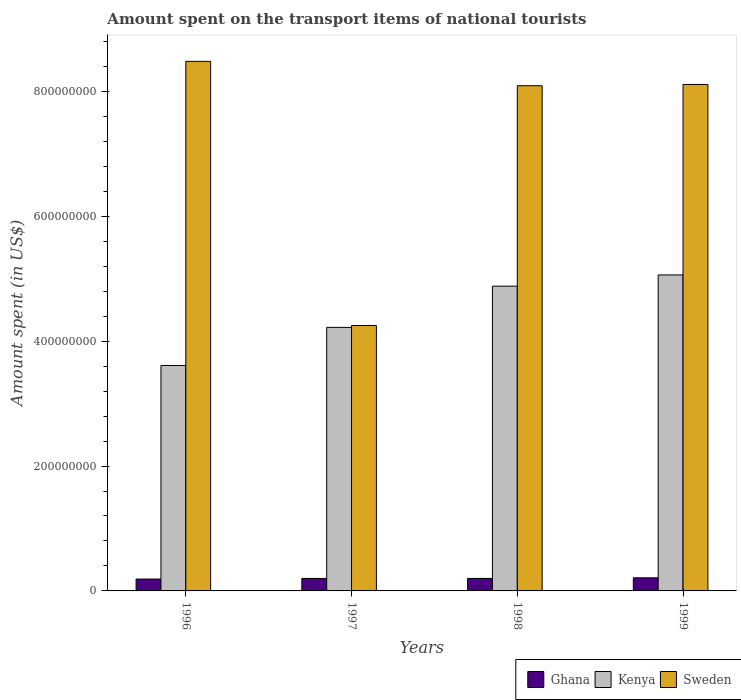How many bars are there on the 4th tick from the left?
Provide a succinct answer. 3. How many bars are there on the 1st tick from the right?
Make the answer very short. 3. What is the amount spent on the transport items of national tourists in Ghana in 1997?
Keep it short and to the point. 2.00e+07. Across all years, what is the maximum amount spent on the transport items of national tourists in Sweden?
Offer a very short reply. 8.48e+08. Across all years, what is the minimum amount spent on the transport items of national tourists in Kenya?
Offer a very short reply. 3.61e+08. In which year was the amount spent on the transport items of national tourists in Kenya maximum?
Your response must be concise. 1999. In which year was the amount spent on the transport items of national tourists in Kenya minimum?
Give a very brief answer. 1996. What is the total amount spent on the transport items of national tourists in Sweden in the graph?
Give a very brief answer. 2.89e+09. What is the difference between the amount spent on the transport items of national tourists in Kenya in 1997 and that in 1999?
Your answer should be very brief. -8.40e+07. What is the difference between the amount spent on the transport items of national tourists in Kenya in 1998 and the amount spent on the transport items of national tourists in Sweden in 1997?
Keep it short and to the point. 6.30e+07. What is the average amount spent on the transport items of national tourists in Kenya per year?
Ensure brevity in your answer.  4.44e+08. In the year 1999, what is the difference between the amount spent on the transport items of national tourists in Sweden and amount spent on the transport items of national tourists in Ghana?
Ensure brevity in your answer.  7.90e+08. What is the ratio of the amount spent on the transport items of national tourists in Kenya in 1998 to that in 1999?
Your response must be concise. 0.96. What is the difference between the highest and the second highest amount spent on the transport items of national tourists in Kenya?
Offer a very short reply. 1.80e+07. What is the difference between the highest and the lowest amount spent on the transport items of national tourists in Ghana?
Provide a succinct answer. 2.00e+06. Is the sum of the amount spent on the transport items of national tourists in Kenya in 1996 and 1998 greater than the maximum amount spent on the transport items of national tourists in Ghana across all years?
Your answer should be very brief. Yes. What does the 2nd bar from the left in 1998 represents?
Make the answer very short. Kenya. Is it the case that in every year, the sum of the amount spent on the transport items of national tourists in Kenya and amount spent on the transport items of national tourists in Ghana is greater than the amount spent on the transport items of national tourists in Sweden?
Provide a succinct answer. No. How many bars are there?
Provide a succinct answer. 12. Are all the bars in the graph horizontal?
Your response must be concise. No. How many years are there in the graph?
Offer a very short reply. 4. What is the difference between two consecutive major ticks on the Y-axis?
Ensure brevity in your answer.  2.00e+08. Are the values on the major ticks of Y-axis written in scientific E-notation?
Ensure brevity in your answer.  No. Where does the legend appear in the graph?
Ensure brevity in your answer.  Bottom right. How many legend labels are there?
Give a very brief answer. 3. What is the title of the graph?
Provide a short and direct response. Amount spent on the transport items of national tourists. Does "High income: nonOECD" appear as one of the legend labels in the graph?
Give a very brief answer. No. What is the label or title of the X-axis?
Your response must be concise. Years. What is the label or title of the Y-axis?
Provide a succinct answer. Amount spent (in US$). What is the Amount spent (in US$) of Ghana in 1996?
Your answer should be very brief. 1.90e+07. What is the Amount spent (in US$) in Kenya in 1996?
Provide a succinct answer. 3.61e+08. What is the Amount spent (in US$) in Sweden in 1996?
Offer a terse response. 8.48e+08. What is the Amount spent (in US$) of Ghana in 1997?
Provide a short and direct response. 2.00e+07. What is the Amount spent (in US$) of Kenya in 1997?
Provide a short and direct response. 4.22e+08. What is the Amount spent (in US$) in Sweden in 1997?
Your answer should be very brief. 4.25e+08. What is the Amount spent (in US$) of Kenya in 1998?
Offer a very short reply. 4.88e+08. What is the Amount spent (in US$) of Sweden in 1998?
Make the answer very short. 8.09e+08. What is the Amount spent (in US$) of Ghana in 1999?
Provide a succinct answer. 2.10e+07. What is the Amount spent (in US$) of Kenya in 1999?
Offer a terse response. 5.06e+08. What is the Amount spent (in US$) of Sweden in 1999?
Keep it short and to the point. 8.11e+08. Across all years, what is the maximum Amount spent (in US$) in Ghana?
Give a very brief answer. 2.10e+07. Across all years, what is the maximum Amount spent (in US$) of Kenya?
Provide a short and direct response. 5.06e+08. Across all years, what is the maximum Amount spent (in US$) in Sweden?
Make the answer very short. 8.48e+08. Across all years, what is the minimum Amount spent (in US$) in Ghana?
Offer a very short reply. 1.90e+07. Across all years, what is the minimum Amount spent (in US$) in Kenya?
Your answer should be compact. 3.61e+08. Across all years, what is the minimum Amount spent (in US$) in Sweden?
Your answer should be compact. 4.25e+08. What is the total Amount spent (in US$) in Ghana in the graph?
Offer a very short reply. 8.00e+07. What is the total Amount spent (in US$) in Kenya in the graph?
Offer a terse response. 1.78e+09. What is the total Amount spent (in US$) in Sweden in the graph?
Provide a short and direct response. 2.89e+09. What is the difference between the Amount spent (in US$) of Ghana in 1996 and that in 1997?
Your answer should be compact. -1.00e+06. What is the difference between the Amount spent (in US$) in Kenya in 1996 and that in 1997?
Your answer should be very brief. -6.10e+07. What is the difference between the Amount spent (in US$) of Sweden in 1996 and that in 1997?
Keep it short and to the point. 4.23e+08. What is the difference between the Amount spent (in US$) in Kenya in 1996 and that in 1998?
Offer a very short reply. -1.27e+08. What is the difference between the Amount spent (in US$) in Sweden in 1996 and that in 1998?
Your answer should be very brief. 3.90e+07. What is the difference between the Amount spent (in US$) of Kenya in 1996 and that in 1999?
Offer a terse response. -1.45e+08. What is the difference between the Amount spent (in US$) in Sweden in 1996 and that in 1999?
Offer a terse response. 3.70e+07. What is the difference between the Amount spent (in US$) of Kenya in 1997 and that in 1998?
Your response must be concise. -6.60e+07. What is the difference between the Amount spent (in US$) in Sweden in 1997 and that in 1998?
Provide a short and direct response. -3.84e+08. What is the difference between the Amount spent (in US$) of Kenya in 1997 and that in 1999?
Offer a very short reply. -8.40e+07. What is the difference between the Amount spent (in US$) in Sweden in 1997 and that in 1999?
Ensure brevity in your answer.  -3.86e+08. What is the difference between the Amount spent (in US$) in Kenya in 1998 and that in 1999?
Ensure brevity in your answer.  -1.80e+07. What is the difference between the Amount spent (in US$) of Ghana in 1996 and the Amount spent (in US$) of Kenya in 1997?
Provide a succinct answer. -4.03e+08. What is the difference between the Amount spent (in US$) of Ghana in 1996 and the Amount spent (in US$) of Sweden in 1997?
Provide a short and direct response. -4.06e+08. What is the difference between the Amount spent (in US$) in Kenya in 1996 and the Amount spent (in US$) in Sweden in 1997?
Provide a short and direct response. -6.40e+07. What is the difference between the Amount spent (in US$) in Ghana in 1996 and the Amount spent (in US$) in Kenya in 1998?
Make the answer very short. -4.69e+08. What is the difference between the Amount spent (in US$) of Ghana in 1996 and the Amount spent (in US$) of Sweden in 1998?
Offer a very short reply. -7.90e+08. What is the difference between the Amount spent (in US$) of Kenya in 1996 and the Amount spent (in US$) of Sweden in 1998?
Ensure brevity in your answer.  -4.48e+08. What is the difference between the Amount spent (in US$) in Ghana in 1996 and the Amount spent (in US$) in Kenya in 1999?
Provide a short and direct response. -4.87e+08. What is the difference between the Amount spent (in US$) of Ghana in 1996 and the Amount spent (in US$) of Sweden in 1999?
Give a very brief answer. -7.92e+08. What is the difference between the Amount spent (in US$) in Kenya in 1996 and the Amount spent (in US$) in Sweden in 1999?
Your answer should be compact. -4.50e+08. What is the difference between the Amount spent (in US$) in Ghana in 1997 and the Amount spent (in US$) in Kenya in 1998?
Keep it short and to the point. -4.68e+08. What is the difference between the Amount spent (in US$) in Ghana in 1997 and the Amount spent (in US$) in Sweden in 1998?
Your answer should be compact. -7.89e+08. What is the difference between the Amount spent (in US$) of Kenya in 1997 and the Amount spent (in US$) of Sweden in 1998?
Ensure brevity in your answer.  -3.87e+08. What is the difference between the Amount spent (in US$) in Ghana in 1997 and the Amount spent (in US$) in Kenya in 1999?
Provide a short and direct response. -4.86e+08. What is the difference between the Amount spent (in US$) of Ghana in 1997 and the Amount spent (in US$) of Sweden in 1999?
Provide a succinct answer. -7.91e+08. What is the difference between the Amount spent (in US$) in Kenya in 1997 and the Amount spent (in US$) in Sweden in 1999?
Your response must be concise. -3.89e+08. What is the difference between the Amount spent (in US$) of Ghana in 1998 and the Amount spent (in US$) of Kenya in 1999?
Provide a succinct answer. -4.86e+08. What is the difference between the Amount spent (in US$) of Ghana in 1998 and the Amount spent (in US$) of Sweden in 1999?
Ensure brevity in your answer.  -7.91e+08. What is the difference between the Amount spent (in US$) of Kenya in 1998 and the Amount spent (in US$) of Sweden in 1999?
Make the answer very short. -3.23e+08. What is the average Amount spent (in US$) of Kenya per year?
Your response must be concise. 4.44e+08. What is the average Amount spent (in US$) of Sweden per year?
Make the answer very short. 7.23e+08. In the year 1996, what is the difference between the Amount spent (in US$) of Ghana and Amount spent (in US$) of Kenya?
Your answer should be very brief. -3.42e+08. In the year 1996, what is the difference between the Amount spent (in US$) of Ghana and Amount spent (in US$) of Sweden?
Your answer should be compact. -8.29e+08. In the year 1996, what is the difference between the Amount spent (in US$) of Kenya and Amount spent (in US$) of Sweden?
Ensure brevity in your answer.  -4.87e+08. In the year 1997, what is the difference between the Amount spent (in US$) of Ghana and Amount spent (in US$) of Kenya?
Keep it short and to the point. -4.02e+08. In the year 1997, what is the difference between the Amount spent (in US$) in Ghana and Amount spent (in US$) in Sweden?
Give a very brief answer. -4.05e+08. In the year 1998, what is the difference between the Amount spent (in US$) of Ghana and Amount spent (in US$) of Kenya?
Offer a terse response. -4.68e+08. In the year 1998, what is the difference between the Amount spent (in US$) in Ghana and Amount spent (in US$) in Sweden?
Ensure brevity in your answer.  -7.89e+08. In the year 1998, what is the difference between the Amount spent (in US$) of Kenya and Amount spent (in US$) of Sweden?
Your response must be concise. -3.21e+08. In the year 1999, what is the difference between the Amount spent (in US$) in Ghana and Amount spent (in US$) in Kenya?
Keep it short and to the point. -4.85e+08. In the year 1999, what is the difference between the Amount spent (in US$) in Ghana and Amount spent (in US$) in Sweden?
Your response must be concise. -7.90e+08. In the year 1999, what is the difference between the Amount spent (in US$) in Kenya and Amount spent (in US$) in Sweden?
Your answer should be very brief. -3.05e+08. What is the ratio of the Amount spent (in US$) in Kenya in 1996 to that in 1997?
Your answer should be compact. 0.86. What is the ratio of the Amount spent (in US$) in Sweden in 1996 to that in 1997?
Provide a short and direct response. 2. What is the ratio of the Amount spent (in US$) in Ghana in 1996 to that in 1998?
Your answer should be compact. 0.95. What is the ratio of the Amount spent (in US$) in Kenya in 1996 to that in 1998?
Offer a terse response. 0.74. What is the ratio of the Amount spent (in US$) of Sweden in 1996 to that in 1998?
Your answer should be very brief. 1.05. What is the ratio of the Amount spent (in US$) in Ghana in 1996 to that in 1999?
Keep it short and to the point. 0.9. What is the ratio of the Amount spent (in US$) in Kenya in 1996 to that in 1999?
Provide a succinct answer. 0.71. What is the ratio of the Amount spent (in US$) in Sweden in 1996 to that in 1999?
Keep it short and to the point. 1.05. What is the ratio of the Amount spent (in US$) of Ghana in 1997 to that in 1998?
Your response must be concise. 1. What is the ratio of the Amount spent (in US$) in Kenya in 1997 to that in 1998?
Ensure brevity in your answer.  0.86. What is the ratio of the Amount spent (in US$) in Sweden in 1997 to that in 1998?
Ensure brevity in your answer.  0.53. What is the ratio of the Amount spent (in US$) of Kenya in 1997 to that in 1999?
Keep it short and to the point. 0.83. What is the ratio of the Amount spent (in US$) of Sweden in 1997 to that in 1999?
Offer a terse response. 0.52. What is the ratio of the Amount spent (in US$) of Ghana in 1998 to that in 1999?
Offer a very short reply. 0.95. What is the ratio of the Amount spent (in US$) of Kenya in 1998 to that in 1999?
Your answer should be very brief. 0.96. What is the difference between the highest and the second highest Amount spent (in US$) in Kenya?
Keep it short and to the point. 1.80e+07. What is the difference between the highest and the second highest Amount spent (in US$) in Sweden?
Offer a terse response. 3.70e+07. What is the difference between the highest and the lowest Amount spent (in US$) of Ghana?
Ensure brevity in your answer.  2.00e+06. What is the difference between the highest and the lowest Amount spent (in US$) of Kenya?
Keep it short and to the point. 1.45e+08. What is the difference between the highest and the lowest Amount spent (in US$) in Sweden?
Offer a very short reply. 4.23e+08. 